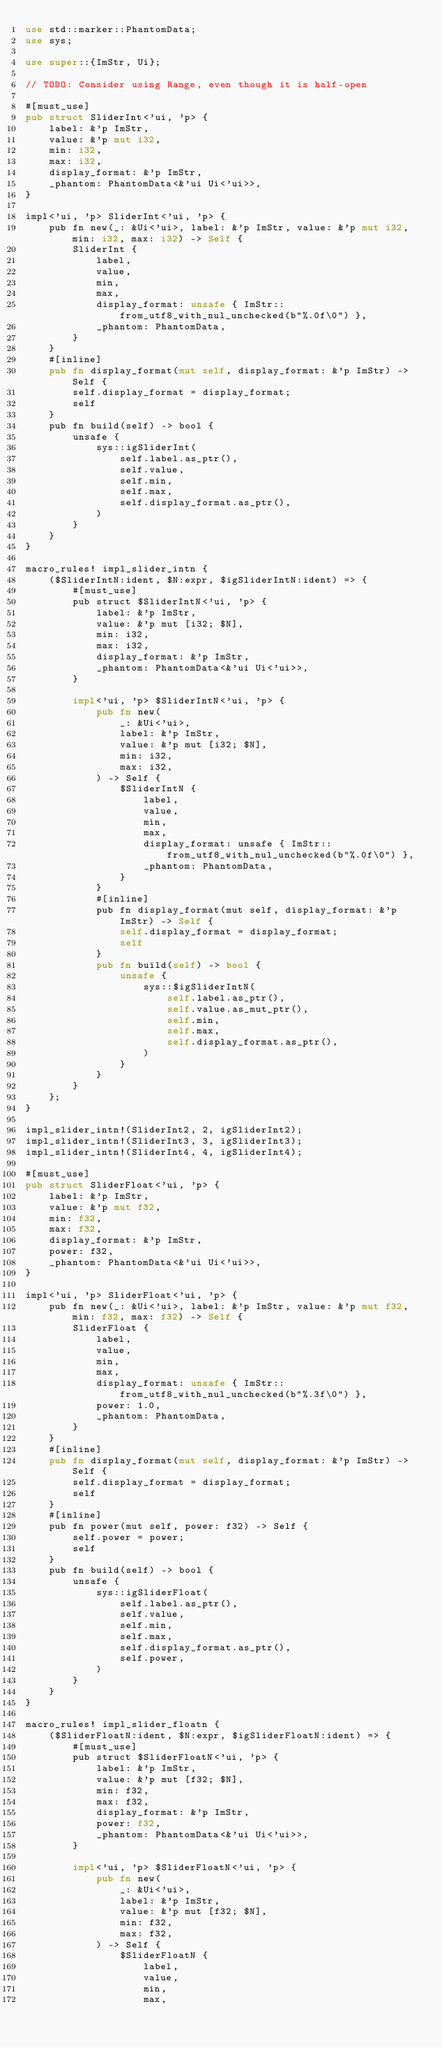Convert code to text. <code><loc_0><loc_0><loc_500><loc_500><_Rust_>use std::marker::PhantomData;
use sys;

use super::{ImStr, Ui};

// TODO: Consider using Range, even though it is half-open

#[must_use]
pub struct SliderInt<'ui, 'p> {
    label: &'p ImStr,
    value: &'p mut i32,
    min: i32,
    max: i32,
    display_format: &'p ImStr,
    _phantom: PhantomData<&'ui Ui<'ui>>,
}

impl<'ui, 'p> SliderInt<'ui, 'p> {
    pub fn new(_: &Ui<'ui>, label: &'p ImStr, value: &'p mut i32, min: i32, max: i32) -> Self {
        SliderInt {
            label,
            value,
            min,
            max,
            display_format: unsafe { ImStr::from_utf8_with_nul_unchecked(b"%.0f\0") },
            _phantom: PhantomData,
        }
    }
    #[inline]
    pub fn display_format(mut self, display_format: &'p ImStr) -> Self {
        self.display_format = display_format;
        self
    }
    pub fn build(self) -> bool {
        unsafe {
            sys::igSliderInt(
                self.label.as_ptr(),
                self.value,
                self.min,
                self.max,
                self.display_format.as_ptr(),
            )
        }
    }
}

macro_rules! impl_slider_intn {
    ($SliderIntN:ident, $N:expr, $igSliderIntN:ident) => {
        #[must_use]
        pub struct $SliderIntN<'ui, 'p> {
            label: &'p ImStr,
            value: &'p mut [i32; $N],
            min: i32,
            max: i32,
            display_format: &'p ImStr,
            _phantom: PhantomData<&'ui Ui<'ui>>,
        }

        impl<'ui, 'p> $SliderIntN<'ui, 'p> {
            pub fn new(
                _: &Ui<'ui>,
                label: &'p ImStr,
                value: &'p mut [i32; $N],
                min: i32,
                max: i32,
            ) -> Self {
                $SliderIntN {
                    label,
                    value,
                    min,
                    max,
                    display_format: unsafe { ImStr::from_utf8_with_nul_unchecked(b"%.0f\0") },
                    _phantom: PhantomData,
                }
            }
            #[inline]
            pub fn display_format(mut self, display_format: &'p ImStr) -> Self {
                self.display_format = display_format;
                self
            }
            pub fn build(self) -> bool {
                unsafe {
                    sys::$igSliderIntN(
                        self.label.as_ptr(),
                        self.value.as_mut_ptr(),
                        self.min,
                        self.max,
                        self.display_format.as_ptr(),
                    )
                }
            }
        }
    };
}

impl_slider_intn!(SliderInt2, 2, igSliderInt2);
impl_slider_intn!(SliderInt3, 3, igSliderInt3);
impl_slider_intn!(SliderInt4, 4, igSliderInt4);

#[must_use]
pub struct SliderFloat<'ui, 'p> {
    label: &'p ImStr,
    value: &'p mut f32,
    min: f32,
    max: f32,
    display_format: &'p ImStr,
    power: f32,
    _phantom: PhantomData<&'ui Ui<'ui>>,
}

impl<'ui, 'p> SliderFloat<'ui, 'p> {
    pub fn new(_: &Ui<'ui>, label: &'p ImStr, value: &'p mut f32, min: f32, max: f32) -> Self {
        SliderFloat {
            label,
            value,
            min,
            max,
            display_format: unsafe { ImStr::from_utf8_with_nul_unchecked(b"%.3f\0") },
            power: 1.0,
            _phantom: PhantomData,
        }
    }
    #[inline]
    pub fn display_format(mut self, display_format: &'p ImStr) -> Self {
        self.display_format = display_format;
        self
    }
    #[inline]
    pub fn power(mut self, power: f32) -> Self {
        self.power = power;
        self
    }
    pub fn build(self) -> bool {
        unsafe {
            sys::igSliderFloat(
                self.label.as_ptr(),
                self.value,
                self.min,
                self.max,
                self.display_format.as_ptr(),
                self.power,
            )
        }
    }
}

macro_rules! impl_slider_floatn {
    ($SliderFloatN:ident, $N:expr, $igSliderFloatN:ident) => {
        #[must_use]
        pub struct $SliderFloatN<'ui, 'p> {
            label: &'p ImStr,
            value: &'p mut [f32; $N],
            min: f32,
            max: f32,
            display_format: &'p ImStr,
            power: f32,
            _phantom: PhantomData<&'ui Ui<'ui>>,
        }

        impl<'ui, 'p> $SliderFloatN<'ui, 'p> {
            pub fn new(
                _: &Ui<'ui>,
                label: &'p ImStr,
                value: &'p mut [f32; $N],
                min: f32,
                max: f32,
            ) -> Self {
                $SliderFloatN {
                    label,
                    value,
                    min,
                    max,</code> 